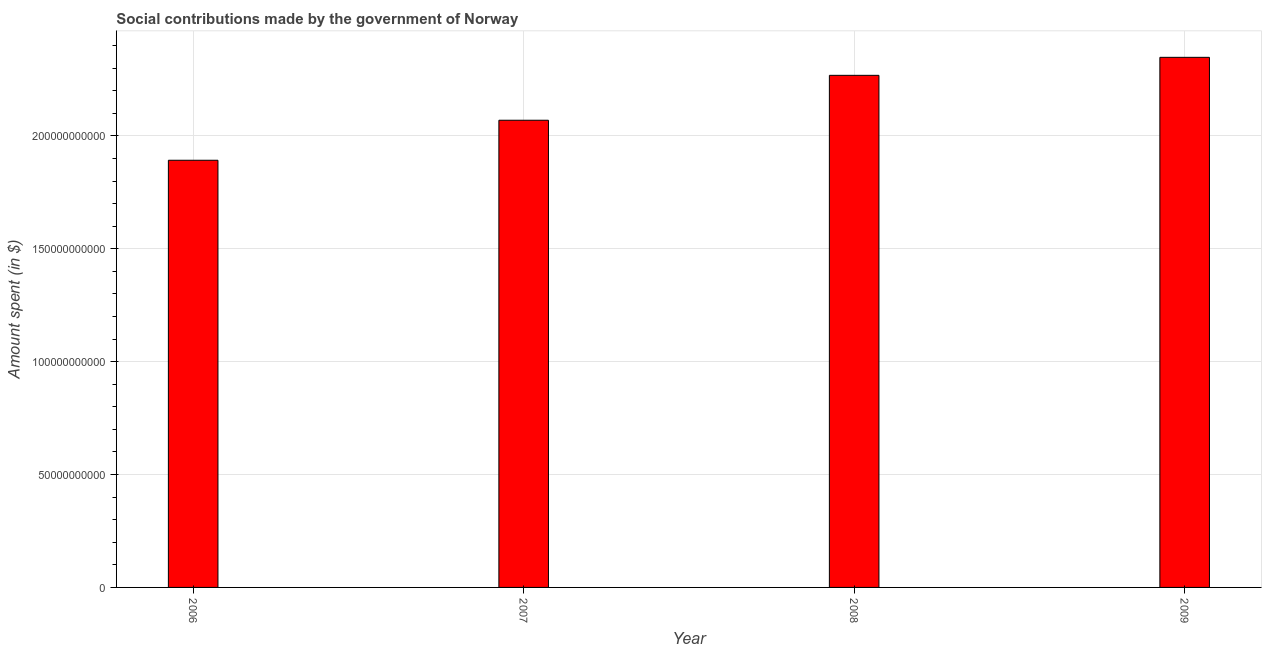Does the graph contain grids?
Offer a terse response. Yes. What is the title of the graph?
Ensure brevity in your answer.  Social contributions made by the government of Norway. What is the label or title of the X-axis?
Your answer should be compact. Year. What is the label or title of the Y-axis?
Your response must be concise. Amount spent (in $). What is the amount spent in making social contributions in 2009?
Provide a short and direct response. 2.35e+11. Across all years, what is the maximum amount spent in making social contributions?
Make the answer very short. 2.35e+11. Across all years, what is the minimum amount spent in making social contributions?
Provide a succinct answer. 1.89e+11. In which year was the amount spent in making social contributions maximum?
Give a very brief answer. 2009. What is the sum of the amount spent in making social contributions?
Make the answer very short. 8.58e+11. What is the difference between the amount spent in making social contributions in 2006 and 2009?
Ensure brevity in your answer.  -4.56e+1. What is the average amount spent in making social contributions per year?
Your response must be concise. 2.14e+11. What is the median amount spent in making social contributions?
Provide a succinct answer. 2.17e+11. In how many years, is the amount spent in making social contributions greater than 160000000000 $?
Your response must be concise. 4. Do a majority of the years between 2008 and 2007 (inclusive) have amount spent in making social contributions greater than 120000000000 $?
Provide a succinct answer. No. What is the ratio of the amount spent in making social contributions in 2006 to that in 2007?
Offer a very short reply. 0.91. Is the amount spent in making social contributions in 2007 less than that in 2009?
Provide a short and direct response. Yes. Is the difference between the amount spent in making social contributions in 2008 and 2009 greater than the difference between any two years?
Give a very brief answer. No. What is the difference between the highest and the second highest amount spent in making social contributions?
Ensure brevity in your answer.  7.98e+09. What is the difference between the highest and the lowest amount spent in making social contributions?
Make the answer very short. 4.56e+1. How many bars are there?
Provide a short and direct response. 4. Are all the bars in the graph horizontal?
Your answer should be very brief. No. How many years are there in the graph?
Your response must be concise. 4. Are the values on the major ticks of Y-axis written in scientific E-notation?
Your answer should be very brief. No. What is the Amount spent (in $) of 2006?
Your response must be concise. 1.89e+11. What is the Amount spent (in $) in 2007?
Your answer should be very brief. 2.07e+11. What is the Amount spent (in $) in 2008?
Your answer should be compact. 2.27e+11. What is the Amount spent (in $) of 2009?
Your response must be concise. 2.35e+11. What is the difference between the Amount spent (in $) in 2006 and 2007?
Your answer should be very brief. -1.77e+1. What is the difference between the Amount spent (in $) in 2006 and 2008?
Give a very brief answer. -3.76e+1. What is the difference between the Amount spent (in $) in 2006 and 2009?
Your answer should be very brief. -4.56e+1. What is the difference between the Amount spent (in $) in 2007 and 2008?
Make the answer very short. -1.99e+1. What is the difference between the Amount spent (in $) in 2007 and 2009?
Your response must be concise. -2.79e+1. What is the difference between the Amount spent (in $) in 2008 and 2009?
Give a very brief answer. -7.98e+09. What is the ratio of the Amount spent (in $) in 2006 to that in 2007?
Keep it short and to the point. 0.91. What is the ratio of the Amount spent (in $) in 2006 to that in 2008?
Your response must be concise. 0.83. What is the ratio of the Amount spent (in $) in 2006 to that in 2009?
Ensure brevity in your answer.  0.81. What is the ratio of the Amount spent (in $) in 2007 to that in 2008?
Make the answer very short. 0.91. What is the ratio of the Amount spent (in $) in 2007 to that in 2009?
Provide a succinct answer. 0.88. 